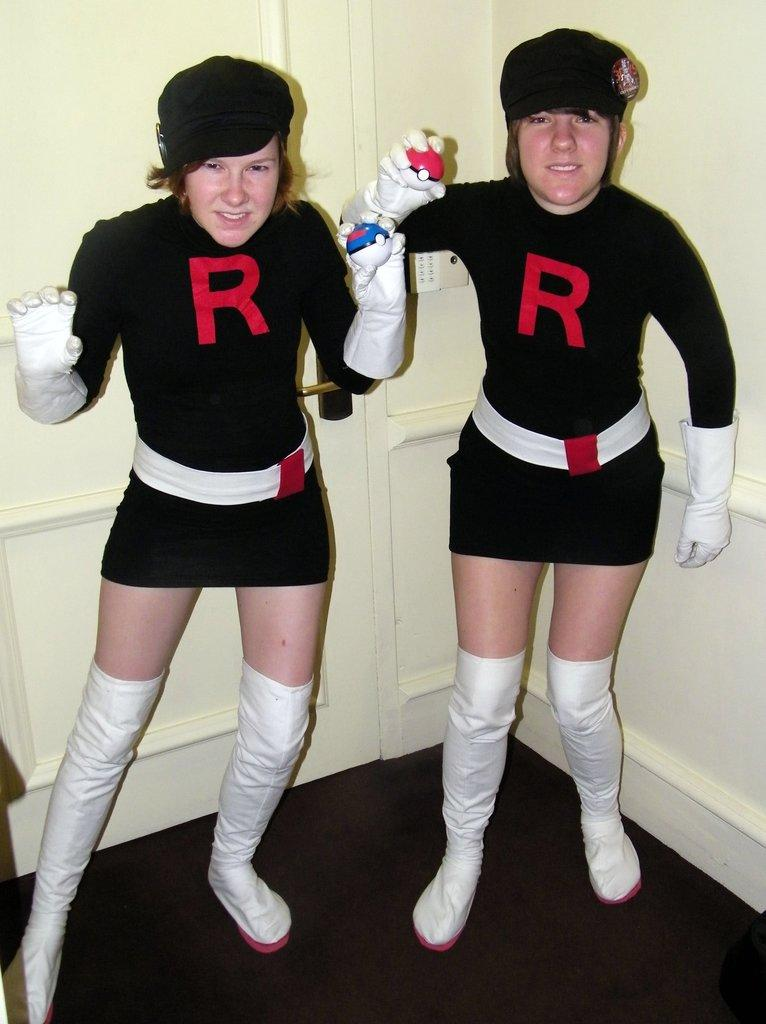<image>
Describe the image concisely. Two women dressed alike with the letter R on their tops and white boots. 